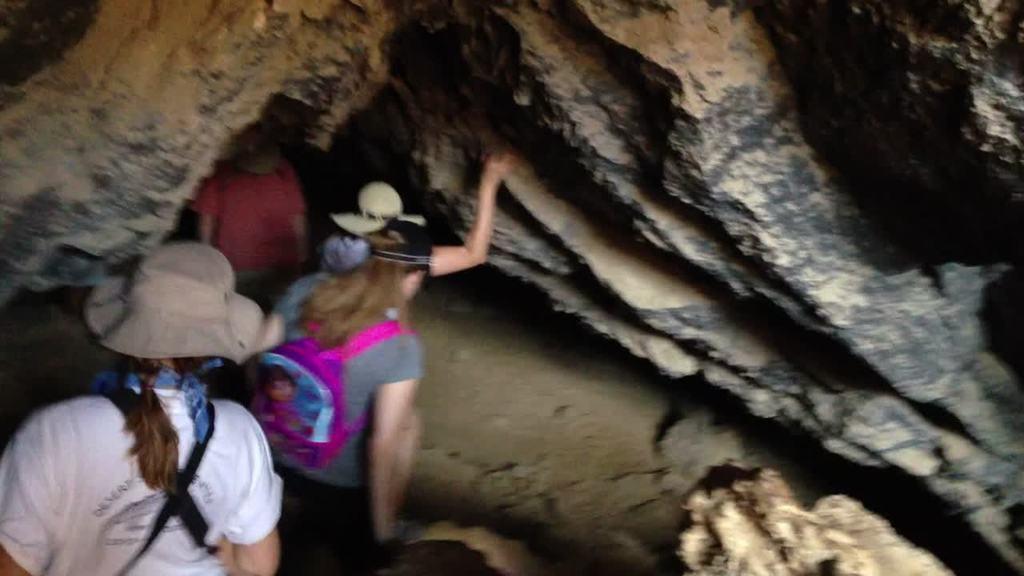Describe this image in one or two sentences. In this image we can see some persons entering into the caves. 